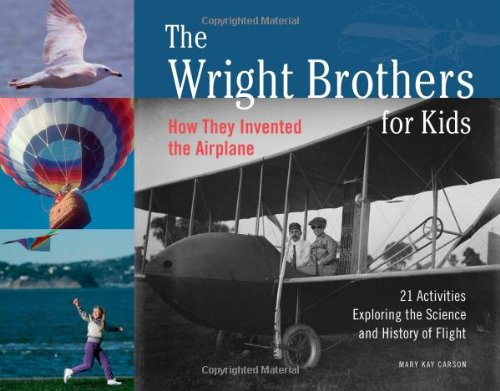Who wrote this book? The book 'The Wright Brothers for Kids' was authored by Mary Kay Carson, a renowned writer known for her works that make science and history accessible to children. 